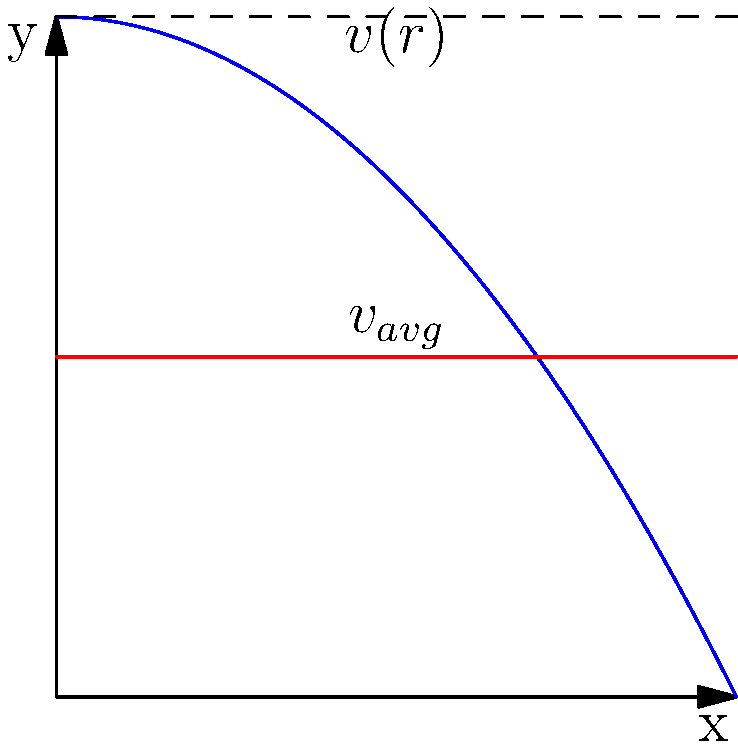In a cylindrical pipe with varying diameter, the velocity profile of a fully developed laminar flow is shown above. The blue curve represents the velocity profile $v(r)$, and the red line represents the average velocity $v_{avg}$. How does this velocity profile relate to the concept of "no-slip condition" at the pipe walls, and what implications does it have for fluid flow in revolutionary contexts? To answer this question, let's break it down step-by-step:

1. The velocity profile shown is parabolic, which is characteristic of fully developed laminar flow in a pipe.

2. The "no-slip condition" states that fluid particles in direct contact with a solid boundary have zero velocity relative to the boundary. This is represented in the graph where $v(r) = 0$ at the pipe walls (edges of the x-axis).

3. The velocity increases from zero at the walls to a maximum at the center of the pipe, forming a parabolic profile described by the equation:

   $$v(r) = v_{max}(1 - \frac{r^2}{R^2})$$

   where $v_{max}$ is the maximum velocity at the center, $r$ is the radial distance from the center, and $R$ is the pipe radius.

4. The average velocity $v_{avg}$ (red line) is lower than the maximum velocity, typically:

   $$v_{avg} = \frac{1}{2}v_{max}$$

5. In the context of Latin American revolutions, this fluid dynamics concept can be metaphorically applied to the spread of revolutionary ideas:
   - The "no-slip condition" at the walls could represent resistance to change in established social structures.
   - The parabolic profile might symbolize how revolutionary ideas gain momentum in the center (among certain social groups) but face resistance at the edges of society.
   - The average velocity could represent the overall pace of social change, which is slower than the maximum velocity of the most active revolutionaries.

6. For women in Latin American revolutions, this model could illustrate:
   - How their participation and influence might have been strongest in certain "central" revolutionary activities but faced more resistance in traditionally male-dominated areas (the "walls" of the societal "pipe").
   - The gradual nature of change in gender roles, with progress happening fastest in the "center" of revolutionary movements but slower at the societal edges.
Answer: The no-slip condition causes zero velocity at pipe walls, creating a parabolic velocity profile that metaphorically represents the spread and resistance of revolutionary ideas in society, particularly relevant to women's roles in Latin American revolutions. 